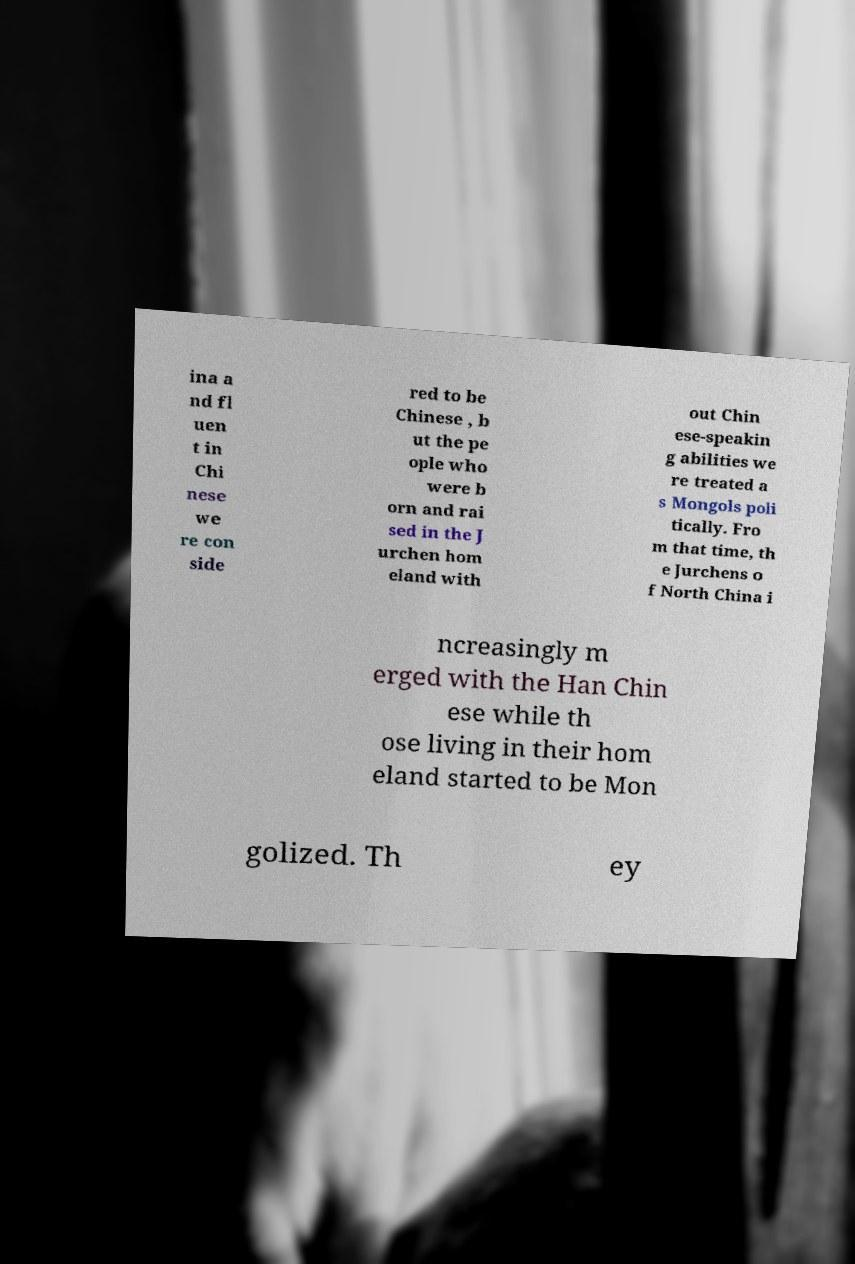Could you extract and type out the text from this image? ina a nd fl uen t in Chi nese we re con side red to be Chinese , b ut the pe ople who were b orn and rai sed in the J urchen hom eland with out Chin ese-speakin g abilities we re treated a s Mongols poli tically. Fro m that time, th e Jurchens o f North China i ncreasingly m erged with the Han Chin ese while th ose living in their hom eland started to be Mon golized. Th ey 